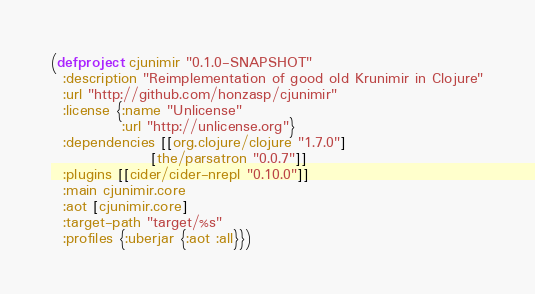Convert code to text. <code><loc_0><loc_0><loc_500><loc_500><_Clojure_>(defproject cjunimir "0.1.0-SNAPSHOT"
  :description "Reimplementation of good old Krunimir in Clojure"
  :url "http://github.com/honzasp/cjunimir"
  :license {:name "Unlicense"
            :url "http://unlicense.org"}
  :dependencies [[org.clojure/clojure "1.7.0"]
                 [the/parsatron "0.0.7"]]
  :plugins [[cider/cider-nrepl "0.10.0"]]
  :main cjunimir.core
  :aot [cjunimir.core]
  :target-path "target/%s"
  :profiles {:uberjar {:aot :all}})
</code> 